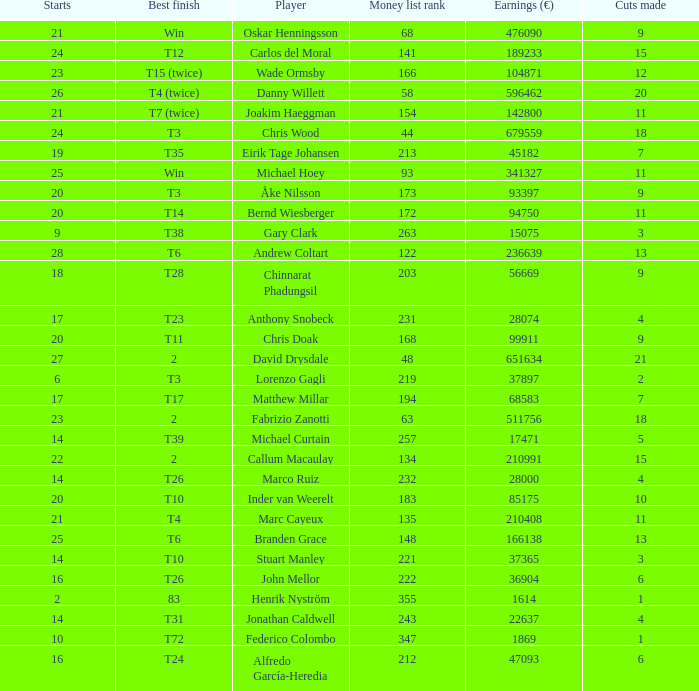How many cuts did Gary Clark make? 3.0. 